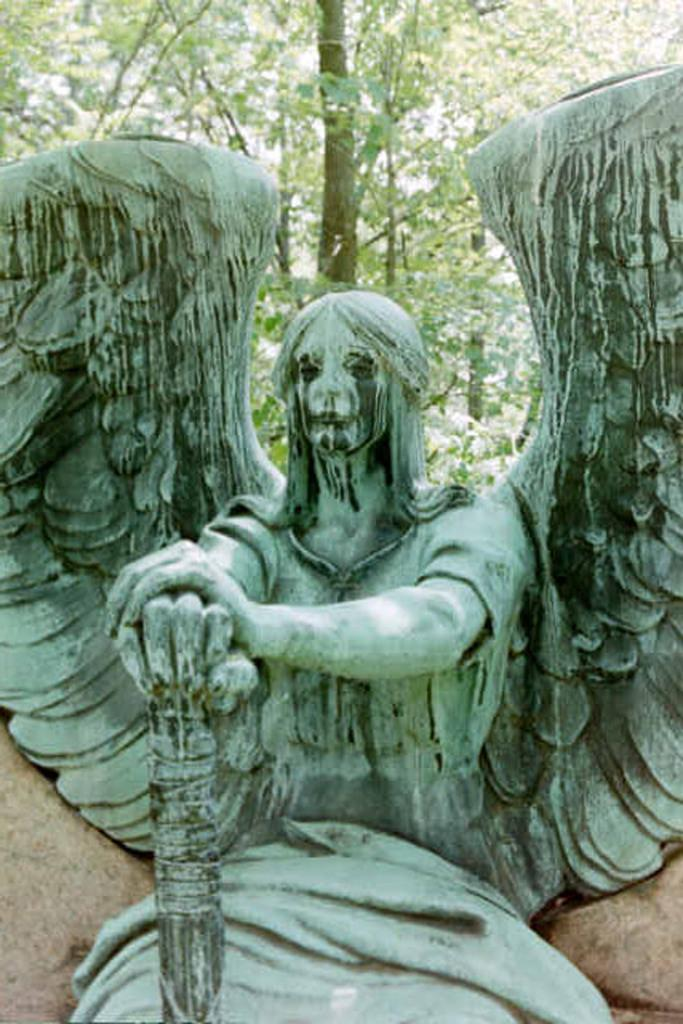What is the main subject in the front of the image? There is a statue in the front of the image. What can be seen in the background of the image? There are trees in the background of the image. How many beds are visible in the image? There are no beds present in the image. What type of son can be seen interacting with the statue in the image? There is no son present in the image, and therefore no such interaction can be observed. 